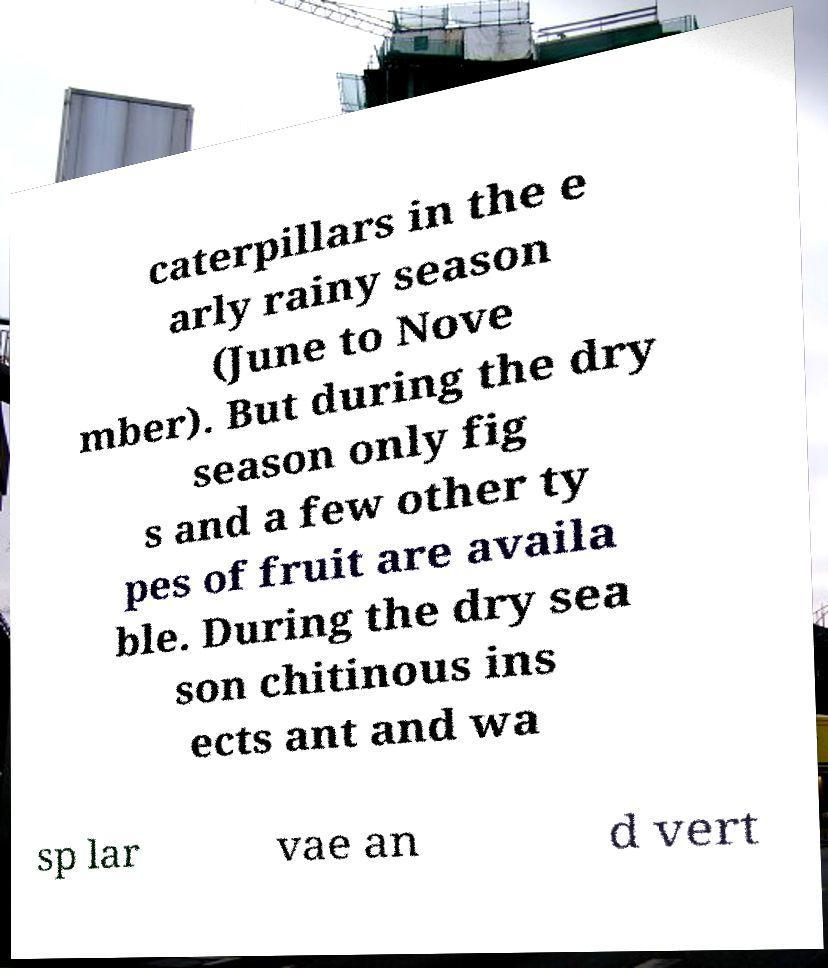I need the written content from this picture converted into text. Can you do that? caterpillars in the e arly rainy season (June to Nove mber). But during the dry season only fig s and a few other ty pes of fruit are availa ble. During the dry sea son chitinous ins ects ant and wa sp lar vae an d vert 